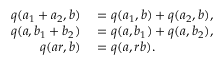<formula> <loc_0><loc_0><loc_500><loc_500>\begin{array} { r l } { q ( a _ { 1 } + a _ { 2 } , b ) } & = q ( a _ { 1 } , b ) + q ( a _ { 2 } , b ) , } \\ { q ( a , b _ { 1 } + b _ { 2 } ) } & = q ( a , b _ { 1 } ) + q ( a , b _ { 2 } ) , } \\ { q ( a r , b ) } & = q ( a , r b ) . } \end{array}</formula> 